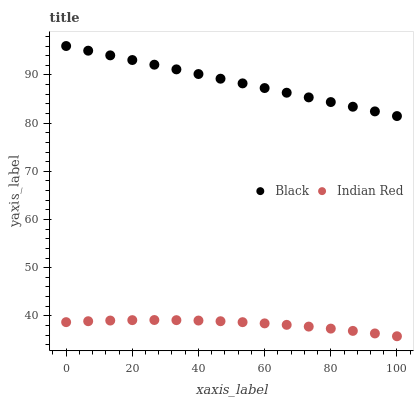Does Indian Red have the minimum area under the curve?
Answer yes or no. Yes. Does Black have the maximum area under the curve?
Answer yes or no. Yes. Does Indian Red have the maximum area under the curve?
Answer yes or no. No. Is Black the smoothest?
Answer yes or no. Yes. Is Indian Red the roughest?
Answer yes or no. Yes. Is Indian Red the smoothest?
Answer yes or no. No. Does Indian Red have the lowest value?
Answer yes or no. Yes. Does Black have the highest value?
Answer yes or no. Yes. Does Indian Red have the highest value?
Answer yes or no. No. Is Indian Red less than Black?
Answer yes or no. Yes. Is Black greater than Indian Red?
Answer yes or no. Yes. Does Indian Red intersect Black?
Answer yes or no. No. 